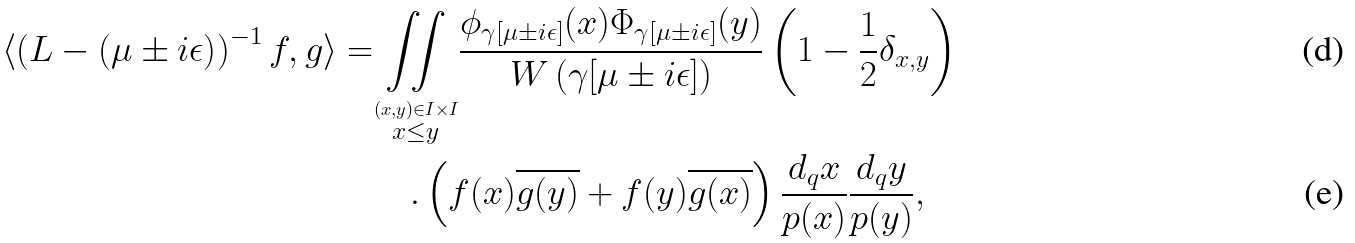<formula> <loc_0><loc_0><loc_500><loc_500>\langle \left ( L - \left ( \mu \pm i \epsilon \right ) \right ) ^ { - 1 } f , g \rangle = & { \underset { \stackrel { ( x , y ) \in I \times I } { x \leq y } } { \iint } } \frac { \phi _ { \gamma [ \mu \pm i \epsilon ] } ( x ) \Phi _ { \gamma [ \mu \pm i \epsilon ] } ( y ) } { W \left ( \gamma [ \mu \pm i \epsilon ] \right ) } \left ( 1 - \frac { 1 } { 2 } \delta _ { x , y } \right ) \\ & \quad . \left ( f ( x ) { \overline { g ( y ) } } + f ( y ) { \overline { g ( x ) } } \right ) \frac { d _ { q } x } { p ( x ) } \frac { d _ { q } y } { p ( y ) } ,</formula> 